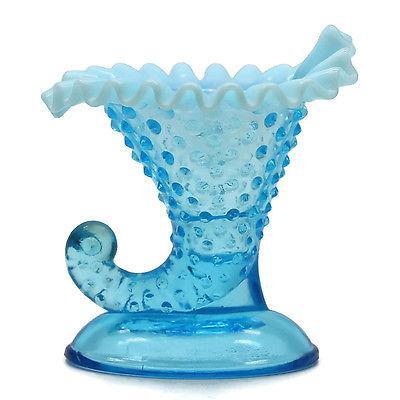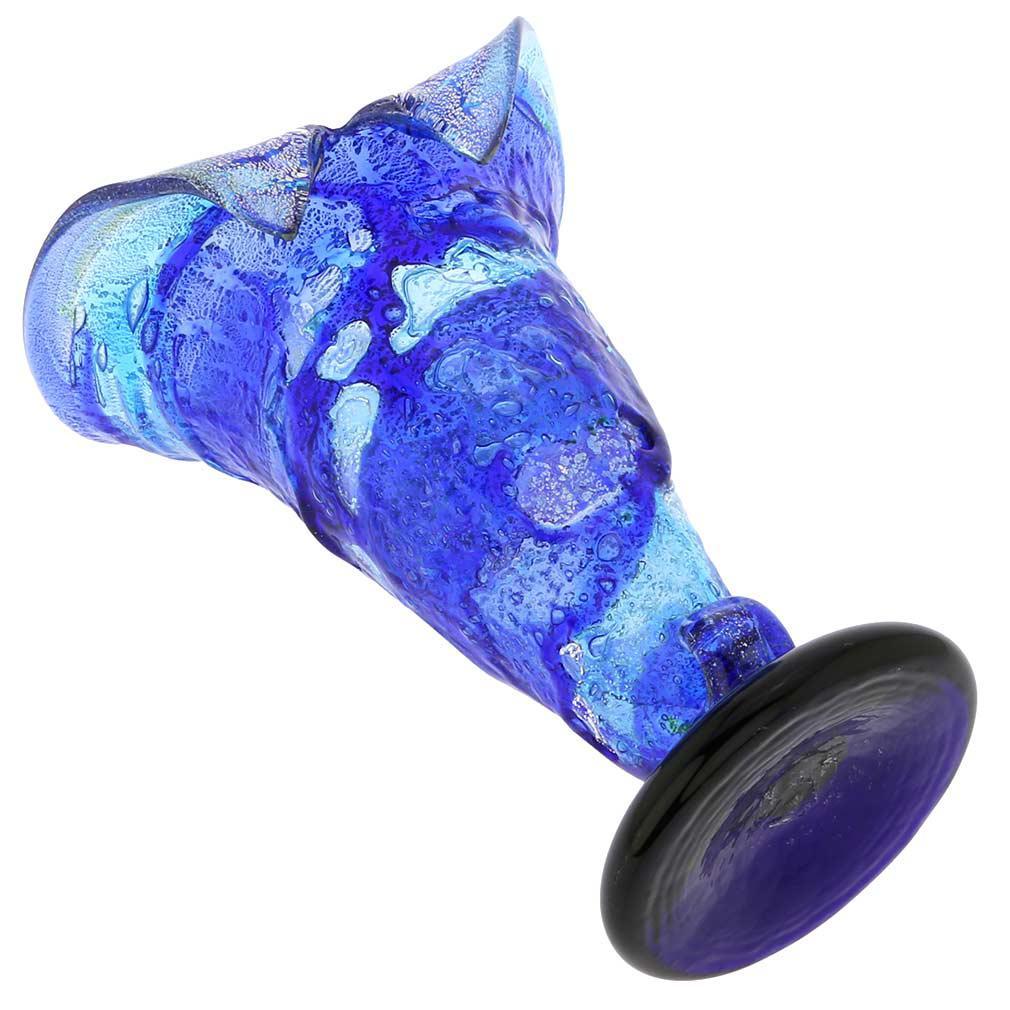The first image is the image on the left, the second image is the image on the right. Considering the images on both sides, is "An image shows one translucent blue vase with a deep blue non-scalloped base." valid? Answer yes or no. Yes. 